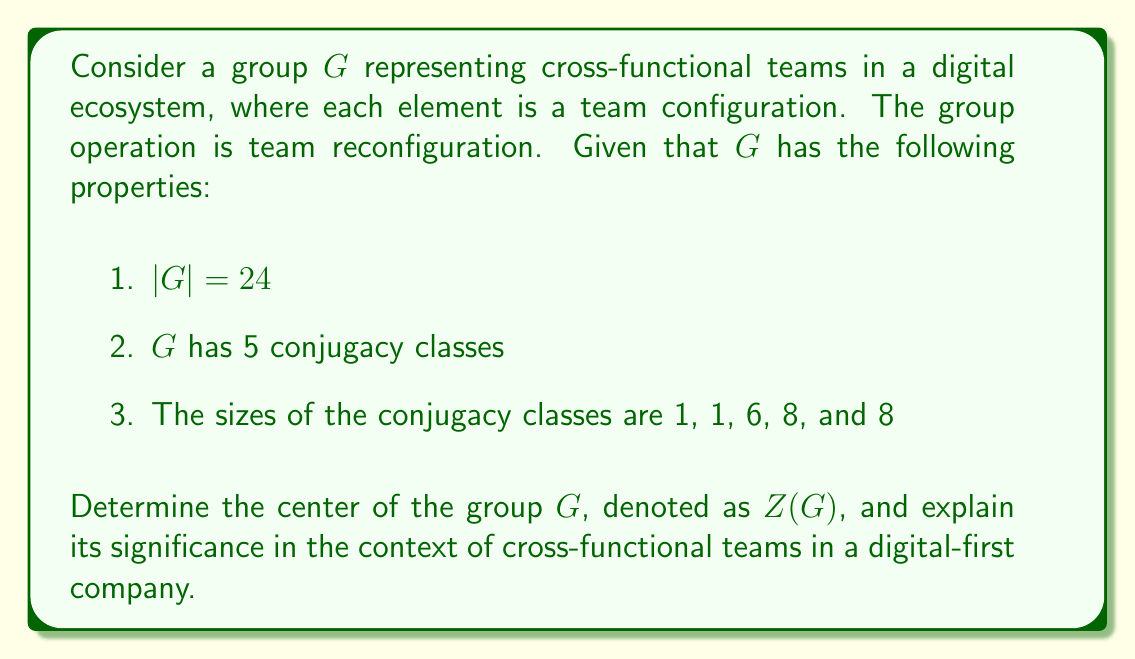Can you answer this question? To solve this problem, we'll follow these steps:

1) Recall that the center of a group $G$ is defined as:
   $$Z(G) = \{z \in G : zg = gz \text{ for all } g \in G\}$$

2) In group theory, elements in the center of a group correspond to conjugacy classes of size 1. This is because if an element commutes with all other elements, it's only conjugate to itself.

3) From the given information, we can see that there are two conjugacy classes of size 1. This means that the center of the group contains two elements.

4) One of these elements must be the identity element, which is always in the center of any group. Let's call the other element $z$.

5) Since $|Z(G)| = 2$, and it contains the identity element and $z$, we can conclude that $Z(G) = \{e, z\}$, where $e$ is the identity element.

6) Moreover, since $|Z(G)| = 2$, we know that $Z(G)$ is isomorphic to the cyclic group of order 2, $C_2$.

In the context of cross-functional teams in a digital-first company:

- The identity element $e$ represents the default team configuration.
- The element $z$ represents a team reconfiguration that, when applied, doesn't change the overall functioning of the digital ecosystem. This could be a fundamental restructuring that all other teams can adapt to without disrupting their core functions.
- The fact that $|Z(G)| = 2$ suggests that there's only one non-trivial team reconfiguration that all other teams can seamlessly work with, emphasizing the importance of this particular configuration in maintaining cross-functional harmony in the digital ecosystem.
Answer: $Z(G) = \{e, z\} \cong C_2$, where $e$ is the identity element and $z$ is a non-trivial element that commutes with all elements in $G$. 